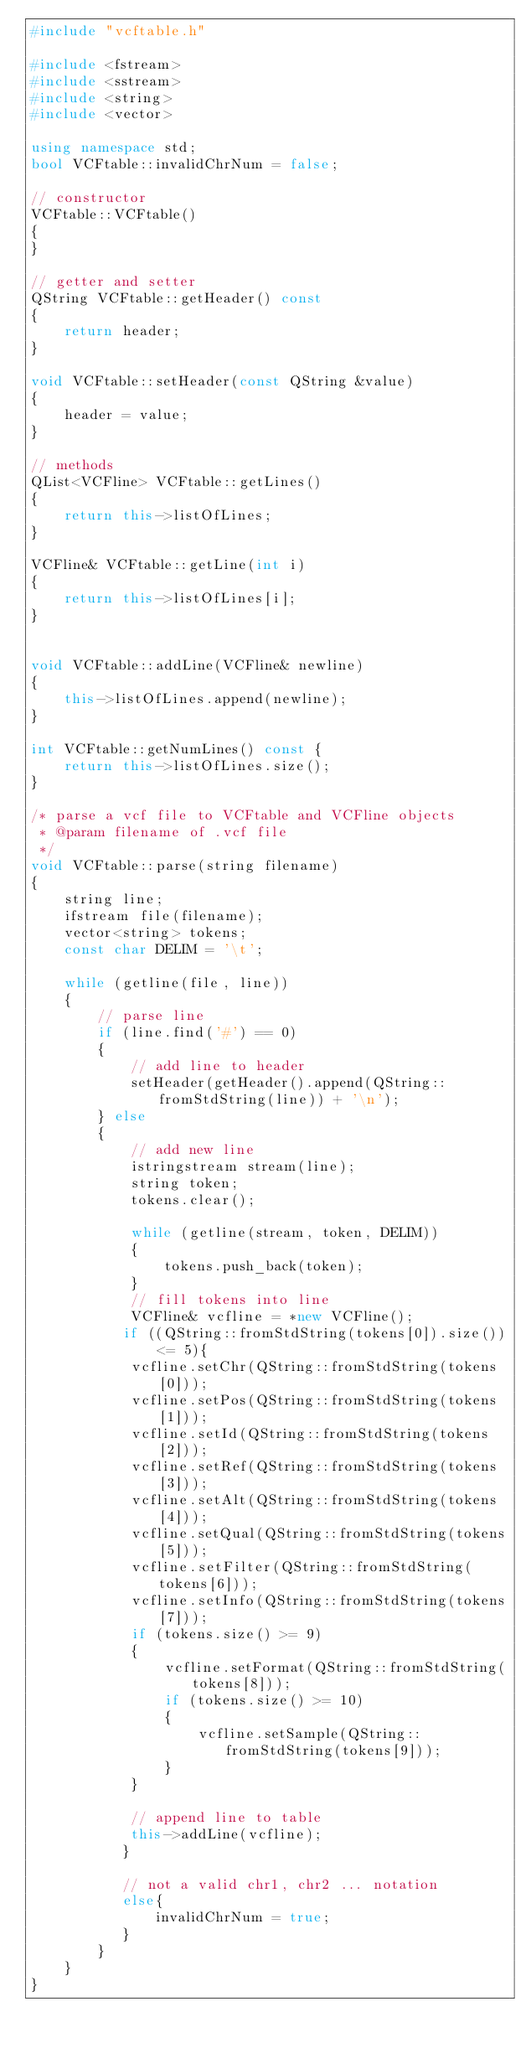Convert code to text. <code><loc_0><loc_0><loc_500><loc_500><_C++_>#include "vcftable.h"

#include <fstream>
#include <sstream>
#include <string>
#include <vector>

using namespace std;
bool VCFtable::invalidChrNum = false;

// constructor
VCFtable::VCFtable()
{
}

// getter and setter
QString VCFtable::getHeader() const
{
    return header;
}

void VCFtable::setHeader(const QString &value)
{
    header = value;
}

// methods
QList<VCFline> VCFtable::getLines()
{
    return this->listOfLines;
}

VCFline& VCFtable::getLine(int i)
{
    return this->listOfLines[i];
}


void VCFtable::addLine(VCFline& newline)
{
    this->listOfLines.append(newline);
}

int VCFtable::getNumLines() const {
    return this->listOfLines.size();
}

/* parse a vcf file to VCFtable and VCFline objects
 * @param filename of .vcf file
 */
void VCFtable::parse(string filename)
{
    string line;
    ifstream file(filename);
    vector<string> tokens;
    const char DELIM = '\t';

    while (getline(file, line))
    {
        // parse line
        if (line.find('#') == 0)
        {
            // add line to header
            setHeader(getHeader().append(QString::fromStdString(line)) + '\n');
        } else
        {
            // add new line
            istringstream stream(line);
            string token;
            tokens.clear();

            while (getline(stream, token, DELIM))
            {
                tokens.push_back(token);
            }
            // fill tokens into line
            VCFline& vcfline = *new VCFline();
           if ((QString::fromStdString(tokens[0]).size()) <= 5){
            vcfline.setChr(QString::fromStdString(tokens[0]));
            vcfline.setPos(QString::fromStdString(tokens[1]));
            vcfline.setId(QString::fromStdString(tokens[2]));
            vcfline.setRef(QString::fromStdString(tokens[3]));
            vcfline.setAlt(QString::fromStdString(tokens[4]));
            vcfline.setQual(QString::fromStdString(tokens[5]));
            vcfline.setFilter(QString::fromStdString(tokens[6]));
            vcfline.setInfo(QString::fromStdString(tokens[7]));
            if (tokens.size() >= 9)
            {
                vcfline.setFormat(QString::fromStdString(tokens[8]));
                if (tokens.size() >= 10)
                {
                    vcfline.setSample(QString::fromStdString(tokens[9]));
                }
            }

            // append line to table
            this->addLine(vcfline);
           }

           // not a valid chr1, chr2 ... notation
           else{
               invalidChrNum = true;
           }
        }
    }
}
</code> 